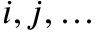<formula> <loc_0><loc_0><loc_500><loc_500>i , j , \dots</formula> 